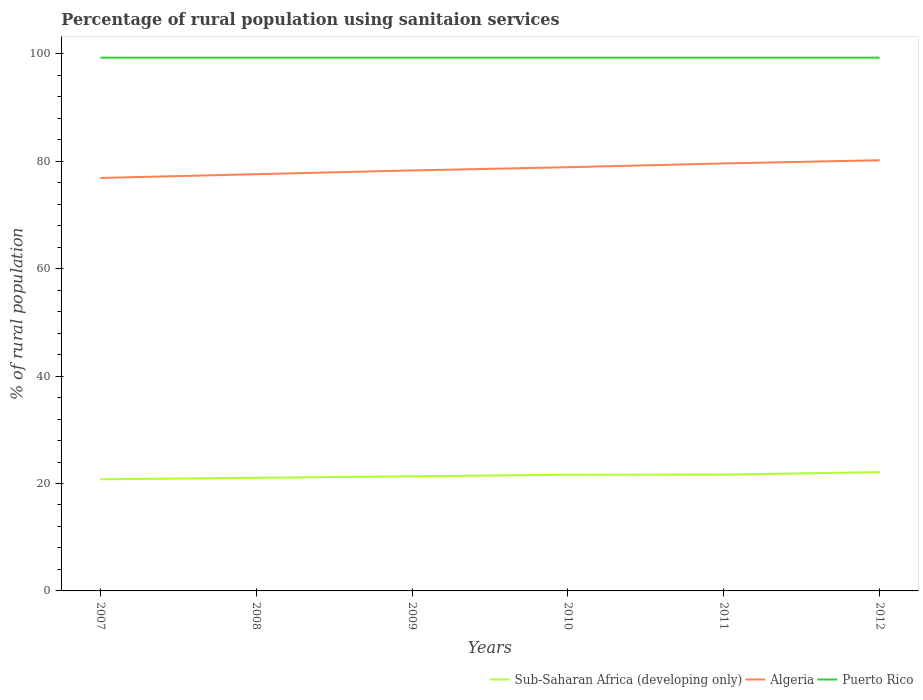Across all years, what is the maximum percentage of rural population using sanitaion services in Puerto Rico?
Your response must be concise. 99.3. What is the total percentage of rural population using sanitaion services in Puerto Rico in the graph?
Provide a succinct answer. 0. What is the difference between the highest and the second highest percentage of rural population using sanitaion services in Algeria?
Make the answer very short. 3.3. What is the difference between the highest and the lowest percentage of rural population using sanitaion services in Algeria?
Offer a very short reply. 3. Is the percentage of rural population using sanitaion services in Sub-Saharan Africa (developing only) strictly greater than the percentage of rural population using sanitaion services in Puerto Rico over the years?
Offer a very short reply. Yes. How many lines are there?
Your response must be concise. 3. How many years are there in the graph?
Give a very brief answer. 6. Does the graph contain any zero values?
Your response must be concise. No. Does the graph contain grids?
Your response must be concise. No. How many legend labels are there?
Keep it short and to the point. 3. How are the legend labels stacked?
Provide a succinct answer. Horizontal. What is the title of the graph?
Keep it short and to the point. Percentage of rural population using sanitaion services. Does "Finland" appear as one of the legend labels in the graph?
Provide a short and direct response. No. What is the label or title of the Y-axis?
Make the answer very short. % of rural population. What is the % of rural population of Sub-Saharan Africa (developing only) in 2007?
Your answer should be compact. 20.79. What is the % of rural population in Algeria in 2007?
Make the answer very short. 76.9. What is the % of rural population of Puerto Rico in 2007?
Provide a short and direct response. 99.3. What is the % of rural population of Sub-Saharan Africa (developing only) in 2008?
Keep it short and to the point. 21.07. What is the % of rural population in Algeria in 2008?
Provide a short and direct response. 77.6. What is the % of rural population of Puerto Rico in 2008?
Provide a succinct answer. 99.3. What is the % of rural population in Sub-Saharan Africa (developing only) in 2009?
Offer a very short reply. 21.34. What is the % of rural population in Algeria in 2009?
Offer a very short reply. 78.3. What is the % of rural population of Puerto Rico in 2009?
Make the answer very short. 99.3. What is the % of rural population of Sub-Saharan Africa (developing only) in 2010?
Offer a very short reply. 21.64. What is the % of rural population of Algeria in 2010?
Keep it short and to the point. 78.9. What is the % of rural population of Puerto Rico in 2010?
Give a very brief answer. 99.3. What is the % of rural population of Sub-Saharan Africa (developing only) in 2011?
Offer a terse response. 21.66. What is the % of rural population of Algeria in 2011?
Offer a terse response. 79.6. What is the % of rural population in Puerto Rico in 2011?
Give a very brief answer. 99.3. What is the % of rural population of Sub-Saharan Africa (developing only) in 2012?
Your answer should be very brief. 22.13. What is the % of rural population of Algeria in 2012?
Your answer should be compact. 80.2. What is the % of rural population of Puerto Rico in 2012?
Your answer should be compact. 99.3. Across all years, what is the maximum % of rural population of Sub-Saharan Africa (developing only)?
Give a very brief answer. 22.13. Across all years, what is the maximum % of rural population of Algeria?
Give a very brief answer. 80.2. Across all years, what is the maximum % of rural population of Puerto Rico?
Your answer should be compact. 99.3. Across all years, what is the minimum % of rural population in Sub-Saharan Africa (developing only)?
Your answer should be very brief. 20.79. Across all years, what is the minimum % of rural population of Algeria?
Offer a very short reply. 76.9. Across all years, what is the minimum % of rural population in Puerto Rico?
Provide a succinct answer. 99.3. What is the total % of rural population in Sub-Saharan Africa (developing only) in the graph?
Keep it short and to the point. 128.62. What is the total % of rural population in Algeria in the graph?
Provide a succinct answer. 471.5. What is the total % of rural population in Puerto Rico in the graph?
Your response must be concise. 595.8. What is the difference between the % of rural population of Sub-Saharan Africa (developing only) in 2007 and that in 2008?
Give a very brief answer. -0.28. What is the difference between the % of rural population in Sub-Saharan Africa (developing only) in 2007 and that in 2009?
Give a very brief answer. -0.55. What is the difference between the % of rural population of Algeria in 2007 and that in 2009?
Ensure brevity in your answer.  -1.4. What is the difference between the % of rural population of Puerto Rico in 2007 and that in 2009?
Make the answer very short. 0. What is the difference between the % of rural population of Sub-Saharan Africa (developing only) in 2007 and that in 2010?
Your answer should be compact. -0.85. What is the difference between the % of rural population in Puerto Rico in 2007 and that in 2010?
Your answer should be very brief. 0. What is the difference between the % of rural population of Sub-Saharan Africa (developing only) in 2007 and that in 2011?
Give a very brief answer. -0.87. What is the difference between the % of rural population in Algeria in 2007 and that in 2011?
Offer a very short reply. -2.7. What is the difference between the % of rural population in Sub-Saharan Africa (developing only) in 2007 and that in 2012?
Offer a terse response. -1.34. What is the difference between the % of rural population of Algeria in 2007 and that in 2012?
Offer a very short reply. -3.3. What is the difference between the % of rural population of Puerto Rico in 2007 and that in 2012?
Ensure brevity in your answer.  0. What is the difference between the % of rural population in Sub-Saharan Africa (developing only) in 2008 and that in 2009?
Provide a short and direct response. -0.28. What is the difference between the % of rural population of Sub-Saharan Africa (developing only) in 2008 and that in 2010?
Provide a short and direct response. -0.57. What is the difference between the % of rural population in Sub-Saharan Africa (developing only) in 2008 and that in 2011?
Make the answer very short. -0.59. What is the difference between the % of rural population in Sub-Saharan Africa (developing only) in 2008 and that in 2012?
Give a very brief answer. -1.06. What is the difference between the % of rural population in Puerto Rico in 2008 and that in 2012?
Make the answer very short. 0. What is the difference between the % of rural population in Sub-Saharan Africa (developing only) in 2009 and that in 2010?
Your answer should be very brief. -0.3. What is the difference between the % of rural population in Algeria in 2009 and that in 2010?
Offer a very short reply. -0.6. What is the difference between the % of rural population in Puerto Rico in 2009 and that in 2010?
Provide a short and direct response. 0. What is the difference between the % of rural population in Sub-Saharan Africa (developing only) in 2009 and that in 2011?
Provide a short and direct response. -0.31. What is the difference between the % of rural population of Algeria in 2009 and that in 2011?
Provide a succinct answer. -1.3. What is the difference between the % of rural population of Sub-Saharan Africa (developing only) in 2009 and that in 2012?
Keep it short and to the point. -0.79. What is the difference between the % of rural population in Puerto Rico in 2009 and that in 2012?
Keep it short and to the point. 0. What is the difference between the % of rural population in Sub-Saharan Africa (developing only) in 2010 and that in 2011?
Offer a terse response. -0.02. What is the difference between the % of rural population in Algeria in 2010 and that in 2011?
Offer a very short reply. -0.7. What is the difference between the % of rural population of Sub-Saharan Africa (developing only) in 2010 and that in 2012?
Offer a very short reply. -0.49. What is the difference between the % of rural population of Puerto Rico in 2010 and that in 2012?
Give a very brief answer. 0. What is the difference between the % of rural population in Sub-Saharan Africa (developing only) in 2011 and that in 2012?
Give a very brief answer. -0.47. What is the difference between the % of rural population of Puerto Rico in 2011 and that in 2012?
Provide a succinct answer. 0. What is the difference between the % of rural population of Sub-Saharan Africa (developing only) in 2007 and the % of rural population of Algeria in 2008?
Give a very brief answer. -56.81. What is the difference between the % of rural population in Sub-Saharan Africa (developing only) in 2007 and the % of rural population in Puerto Rico in 2008?
Ensure brevity in your answer.  -78.51. What is the difference between the % of rural population in Algeria in 2007 and the % of rural population in Puerto Rico in 2008?
Provide a short and direct response. -22.4. What is the difference between the % of rural population of Sub-Saharan Africa (developing only) in 2007 and the % of rural population of Algeria in 2009?
Provide a short and direct response. -57.51. What is the difference between the % of rural population of Sub-Saharan Africa (developing only) in 2007 and the % of rural population of Puerto Rico in 2009?
Your answer should be very brief. -78.51. What is the difference between the % of rural population of Algeria in 2007 and the % of rural population of Puerto Rico in 2009?
Give a very brief answer. -22.4. What is the difference between the % of rural population in Sub-Saharan Africa (developing only) in 2007 and the % of rural population in Algeria in 2010?
Your response must be concise. -58.11. What is the difference between the % of rural population in Sub-Saharan Africa (developing only) in 2007 and the % of rural population in Puerto Rico in 2010?
Provide a succinct answer. -78.51. What is the difference between the % of rural population of Algeria in 2007 and the % of rural population of Puerto Rico in 2010?
Your answer should be compact. -22.4. What is the difference between the % of rural population in Sub-Saharan Africa (developing only) in 2007 and the % of rural population in Algeria in 2011?
Provide a succinct answer. -58.81. What is the difference between the % of rural population of Sub-Saharan Africa (developing only) in 2007 and the % of rural population of Puerto Rico in 2011?
Your answer should be very brief. -78.51. What is the difference between the % of rural population of Algeria in 2007 and the % of rural population of Puerto Rico in 2011?
Offer a terse response. -22.4. What is the difference between the % of rural population in Sub-Saharan Africa (developing only) in 2007 and the % of rural population in Algeria in 2012?
Ensure brevity in your answer.  -59.41. What is the difference between the % of rural population in Sub-Saharan Africa (developing only) in 2007 and the % of rural population in Puerto Rico in 2012?
Your response must be concise. -78.51. What is the difference between the % of rural population of Algeria in 2007 and the % of rural population of Puerto Rico in 2012?
Your response must be concise. -22.4. What is the difference between the % of rural population in Sub-Saharan Africa (developing only) in 2008 and the % of rural population in Algeria in 2009?
Offer a very short reply. -57.23. What is the difference between the % of rural population of Sub-Saharan Africa (developing only) in 2008 and the % of rural population of Puerto Rico in 2009?
Your answer should be compact. -78.23. What is the difference between the % of rural population of Algeria in 2008 and the % of rural population of Puerto Rico in 2009?
Your answer should be very brief. -21.7. What is the difference between the % of rural population in Sub-Saharan Africa (developing only) in 2008 and the % of rural population in Algeria in 2010?
Make the answer very short. -57.83. What is the difference between the % of rural population in Sub-Saharan Africa (developing only) in 2008 and the % of rural population in Puerto Rico in 2010?
Provide a succinct answer. -78.23. What is the difference between the % of rural population in Algeria in 2008 and the % of rural population in Puerto Rico in 2010?
Make the answer very short. -21.7. What is the difference between the % of rural population in Sub-Saharan Africa (developing only) in 2008 and the % of rural population in Algeria in 2011?
Offer a very short reply. -58.53. What is the difference between the % of rural population in Sub-Saharan Africa (developing only) in 2008 and the % of rural population in Puerto Rico in 2011?
Offer a very short reply. -78.23. What is the difference between the % of rural population of Algeria in 2008 and the % of rural population of Puerto Rico in 2011?
Make the answer very short. -21.7. What is the difference between the % of rural population in Sub-Saharan Africa (developing only) in 2008 and the % of rural population in Algeria in 2012?
Give a very brief answer. -59.13. What is the difference between the % of rural population of Sub-Saharan Africa (developing only) in 2008 and the % of rural population of Puerto Rico in 2012?
Provide a succinct answer. -78.23. What is the difference between the % of rural population of Algeria in 2008 and the % of rural population of Puerto Rico in 2012?
Provide a succinct answer. -21.7. What is the difference between the % of rural population of Sub-Saharan Africa (developing only) in 2009 and the % of rural population of Algeria in 2010?
Your answer should be very brief. -57.56. What is the difference between the % of rural population in Sub-Saharan Africa (developing only) in 2009 and the % of rural population in Puerto Rico in 2010?
Make the answer very short. -77.96. What is the difference between the % of rural population in Sub-Saharan Africa (developing only) in 2009 and the % of rural population in Algeria in 2011?
Your answer should be very brief. -58.26. What is the difference between the % of rural population of Sub-Saharan Africa (developing only) in 2009 and the % of rural population of Puerto Rico in 2011?
Provide a succinct answer. -77.96. What is the difference between the % of rural population of Algeria in 2009 and the % of rural population of Puerto Rico in 2011?
Give a very brief answer. -21. What is the difference between the % of rural population in Sub-Saharan Africa (developing only) in 2009 and the % of rural population in Algeria in 2012?
Your answer should be compact. -58.86. What is the difference between the % of rural population in Sub-Saharan Africa (developing only) in 2009 and the % of rural population in Puerto Rico in 2012?
Provide a succinct answer. -77.96. What is the difference between the % of rural population in Sub-Saharan Africa (developing only) in 2010 and the % of rural population in Algeria in 2011?
Keep it short and to the point. -57.96. What is the difference between the % of rural population of Sub-Saharan Africa (developing only) in 2010 and the % of rural population of Puerto Rico in 2011?
Give a very brief answer. -77.66. What is the difference between the % of rural population in Algeria in 2010 and the % of rural population in Puerto Rico in 2011?
Your answer should be compact. -20.4. What is the difference between the % of rural population in Sub-Saharan Africa (developing only) in 2010 and the % of rural population in Algeria in 2012?
Your answer should be compact. -58.56. What is the difference between the % of rural population of Sub-Saharan Africa (developing only) in 2010 and the % of rural population of Puerto Rico in 2012?
Offer a very short reply. -77.66. What is the difference between the % of rural population in Algeria in 2010 and the % of rural population in Puerto Rico in 2012?
Your answer should be very brief. -20.4. What is the difference between the % of rural population in Sub-Saharan Africa (developing only) in 2011 and the % of rural population in Algeria in 2012?
Make the answer very short. -58.54. What is the difference between the % of rural population in Sub-Saharan Africa (developing only) in 2011 and the % of rural population in Puerto Rico in 2012?
Offer a very short reply. -77.64. What is the difference between the % of rural population of Algeria in 2011 and the % of rural population of Puerto Rico in 2012?
Provide a succinct answer. -19.7. What is the average % of rural population in Sub-Saharan Africa (developing only) per year?
Offer a terse response. 21.44. What is the average % of rural population in Algeria per year?
Your answer should be very brief. 78.58. What is the average % of rural population of Puerto Rico per year?
Your answer should be very brief. 99.3. In the year 2007, what is the difference between the % of rural population of Sub-Saharan Africa (developing only) and % of rural population of Algeria?
Your answer should be very brief. -56.11. In the year 2007, what is the difference between the % of rural population in Sub-Saharan Africa (developing only) and % of rural population in Puerto Rico?
Keep it short and to the point. -78.51. In the year 2007, what is the difference between the % of rural population of Algeria and % of rural population of Puerto Rico?
Your answer should be compact. -22.4. In the year 2008, what is the difference between the % of rural population in Sub-Saharan Africa (developing only) and % of rural population in Algeria?
Your answer should be compact. -56.53. In the year 2008, what is the difference between the % of rural population of Sub-Saharan Africa (developing only) and % of rural population of Puerto Rico?
Offer a terse response. -78.23. In the year 2008, what is the difference between the % of rural population of Algeria and % of rural population of Puerto Rico?
Your answer should be compact. -21.7. In the year 2009, what is the difference between the % of rural population in Sub-Saharan Africa (developing only) and % of rural population in Algeria?
Provide a succinct answer. -56.96. In the year 2009, what is the difference between the % of rural population in Sub-Saharan Africa (developing only) and % of rural population in Puerto Rico?
Keep it short and to the point. -77.96. In the year 2009, what is the difference between the % of rural population in Algeria and % of rural population in Puerto Rico?
Ensure brevity in your answer.  -21. In the year 2010, what is the difference between the % of rural population of Sub-Saharan Africa (developing only) and % of rural population of Algeria?
Keep it short and to the point. -57.26. In the year 2010, what is the difference between the % of rural population of Sub-Saharan Africa (developing only) and % of rural population of Puerto Rico?
Your answer should be very brief. -77.66. In the year 2010, what is the difference between the % of rural population in Algeria and % of rural population in Puerto Rico?
Make the answer very short. -20.4. In the year 2011, what is the difference between the % of rural population of Sub-Saharan Africa (developing only) and % of rural population of Algeria?
Give a very brief answer. -57.94. In the year 2011, what is the difference between the % of rural population in Sub-Saharan Africa (developing only) and % of rural population in Puerto Rico?
Your answer should be compact. -77.64. In the year 2011, what is the difference between the % of rural population of Algeria and % of rural population of Puerto Rico?
Provide a succinct answer. -19.7. In the year 2012, what is the difference between the % of rural population of Sub-Saharan Africa (developing only) and % of rural population of Algeria?
Offer a very short reply. -58.07. In the year 2012, what is the difference between the % of rural population of Sub-Saharan Africa (developing only) and % of rural population of Puerto Rico?
Ensure brevity in your answer.  -77.17. In the year 2012, what is the difference between the % of rural population of Algeria and % of rural population of Puerto Rico?
Keep it short and to the point. -19.1. What is the ratio of the % of rural population of Sub-Saharan Africa (developing only) in 2007 to that in 2008?
Ensure brevity in your answer.  0.99. What is the ratio of the % of rural population of Puerto Rico in 2007 to that in 2008?
Your answer should be compact. 1. What is the ratio of the % of rural population of Sub-Saharan Africa (developing only) in 2007 to that in 2009?
Ensure brevity in your answer.  0.97. What is the ratio of the % of rural population of Algeria in 2007 to that in 2009?
Provide a short and direct response. 0.98. What is the ratio of the % of rural population of Sub-Saharan Africa (developing only) in 2007 to that in 2010?
Keep it short and to the point. 0.96. What is the ratio of the % of rural population of Algeria in 2007 to that in 2010?
Offer a very short reply. 0.97. What is the ratio of the % of rural population in Sub-Saharan Africa (developing only) in 2007 to that in 2011?
Offer a terse response. 0.96. What is the ratio of the % of rural population of Algeria in 2007 to that in 2011?
Your response must be concise. 0.97. What is the ratio of the % of rural population in Puerto Rico in 2007 to that in 2011?
Your answer should be very brief. 1. What is the ratio of the % of rural population of Sub-Saharan Africa (developing only) in 2007 to that in 2012?
Your answer should be compact. 0.94. What is the ratio of the % of rural population of Algeria in 2007 to that in 2012?
Provide a succinct answer. 0.96. What is the ratio of the % of rural population in Sub-Saharan Africa (developing only) in 2008 to that in 2009?
Provide a succinct answer. 0.99. What is the ratio of the % of rural population in Algeria in 2008 to that in 2009?
Provide a short and direct response. 0.99. What is the ratio of the % of rural population of Sub-Saharan Africa (developing only) in 2008 to that in 2010?
Provide a short and direct response. 0.97. What is the ratio of the % of rural population of Algeria in 2008 to that in 2010?
Keep it short and to the point. 0.98. What is the ratio of the % of rural population in Sub-Saharan Africa (developing only) in 2008 to that in 2011?
Provide a short and direct response. 0.97. What is the ratio of the % of rural population of Algeria in 2008 to that in 2011?
Provide a succinct answer. 0.97. What is the ratio of the % of rural population of Puerto Rico in 2008 to that in 2011?
Give a very brief answer. 1. What is the ratio of the % of rural population of Sub-Saharan Africa (developing only) in 2008 to that in 2012?
Your answer should be very brief. 0.95. What is the ratio of the % of rural population of Algeria in 2008 to that in 2012?
Your answer should be very brief. 0.97. What is the ratio of the % of rural population of Puerto Rico in 2008 to that in 2012?
Offer a terse response. 1. What is the ratio of the % of rural population of Sub-Saharan Africa (developing only) in 2009 to that in 2010?
Make the answer very short. 0.99. What is the ratio of the % of rural population in Puerto Rico in 2009 to that in 2010?
Your response must be concise. 1. What is the ratio of the % of rural population in Sub-Saharan Africa (developing only) in 2009 to that in 2011?
Your answer should be compact. 0.99. What is the ratio of the % of rural population in Algeria in 2009 to that in 2011?
Your answer should be compact. 0.98. What is the ratio of the % of rural population in Puerto Rico in 2009 to that in 2011?
Offer a terse response. 1. What is the ratio of the % of rural population of Sub-Saharan Africa (developing only) in 2009 to that in 2012?
Your answer should be compact. 0.96. What is the ratio of the % of rural population of Algeria in 2009 to that in 2012?
Your answer should be compact. 0.98. What is the ratio of the % of rural population in Puerto Rico in 2009 to that in 2012?
Make the answer very short. 1. What is the ratio of the % of rural population of Sub-Saharan Africa (developing only) in 2010 to that in 2011?
Offer a very short reply. 1. What is the ratio of the % of rural population of Algeria in 2010 to that in 2011?
Provide a short and direct response. 0.99. What is the ratio of the % of rural population in Puerto Rico in 2010 to that in 2011?
Make the answer very short. 1. What is the ratio of the % of rural population in Sub-Saharan Africa (developing only) in 2010 to that in 2012?
Offer a very short reply. 0.98. What is the ratio of the % of rural population in Algeria in 2010 to that in 2012?
Your response must be concise. 0.98. What is the ratio of the % of rural population of Sub-Saharan Africa (developing only) in 2011 to that in 2012?
Make the answer very short. 0.98. What is the ratio of the % of rural population of Algeria in 2011 to that in 2012?
Ensure brevity in your answer.  0.99. What is the ratio of the % of rural population in Puerto Rico in 2011 to that in 2012?
Your response must be concise. 1. What is the difference between the highest and the second highest % of rural population in Sub-Saharan Africa (developing only)?
Your answer should be compact. 0.47. What is the difference between the highest and the second highest % of rural population in Algeria?
Your answer should be very brief. 0.6. What is the difference between the highest and the second highest % of rural population of Puerto Rico?
Your response must be concise. 0. What is the difference between the highest and the lowest % of rural population in Sub-Saharan Africa (developing only)?
Give a very brief answer. 1.34. 